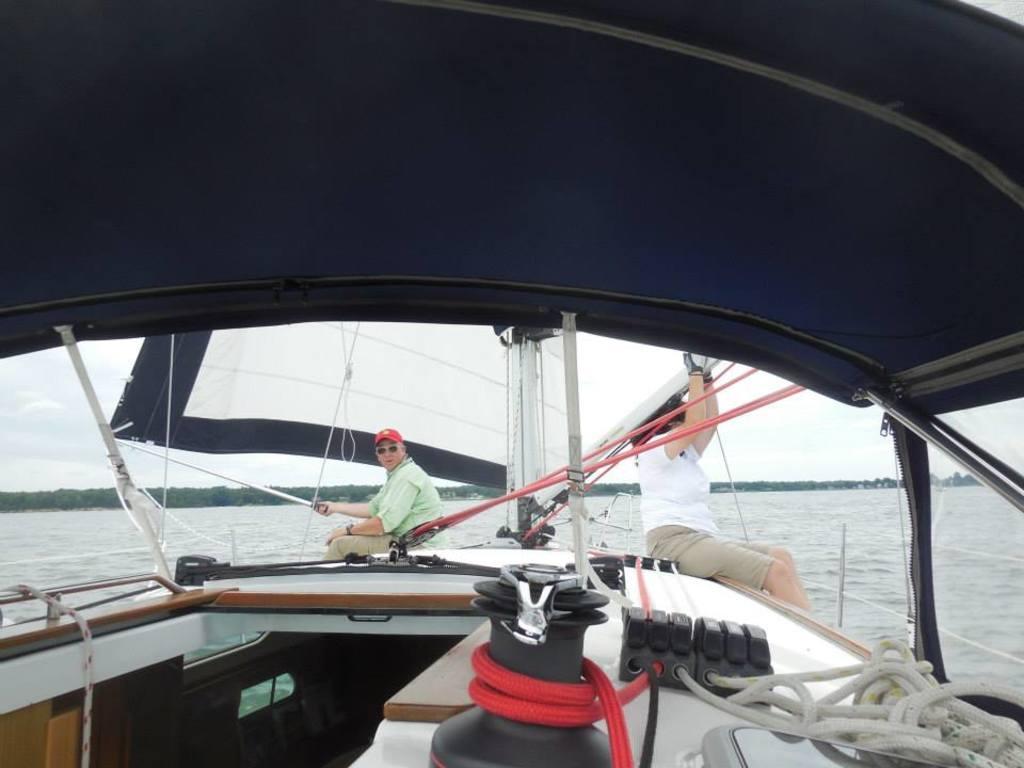How would you summarize this image in a sentence or two? In this picture I can see two persons sitting on the boat, which is on the water, there are trees, and in the background there is the sky. 